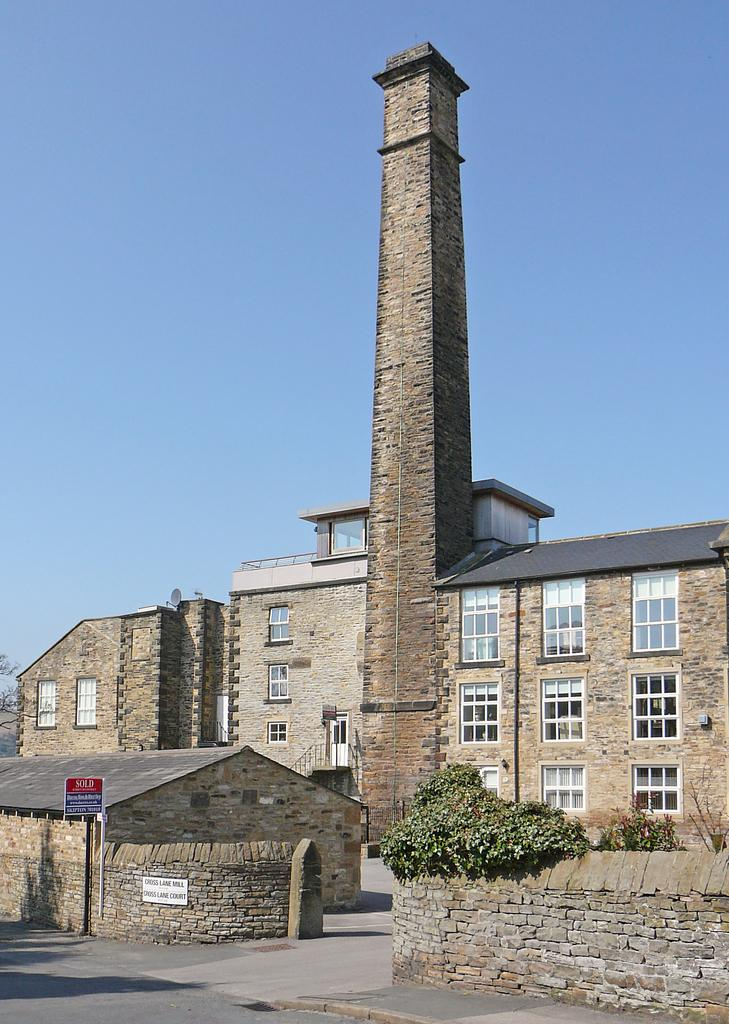What type of structures are located in the center of the image? There are buildings in the center of the image. What can be found at the bottom of the image? There is a shed, a board, and trees at the bottom of the image. What is visible in the background of the image? There is sky visible in the background of the image. Can you see any poisonous plants near the tooth in the image? There is no tooth or poisonous plants present in the image. 